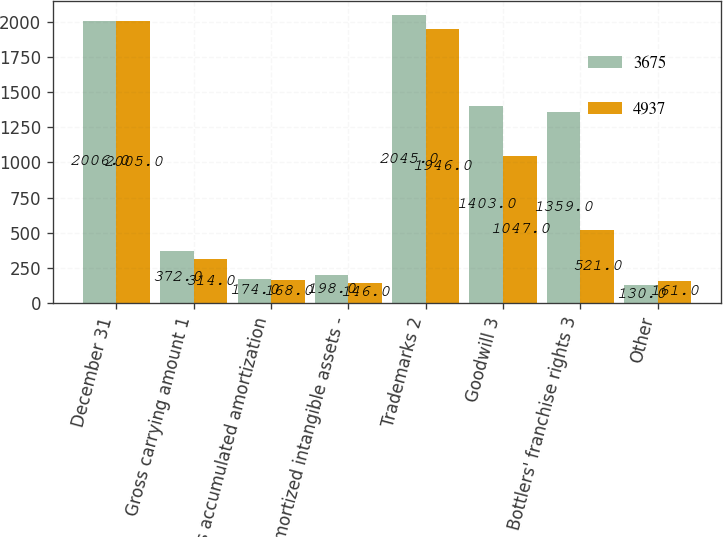Convert chart. <chart><loc_0><loc_0><loc_500><loc_500><stacked_bar_chart><ecel><fcel>December 31<fcel>Gross carrying amount 1<fcel>Less accumulated amortization<fcel>Amortized intangible assets -<fcel>Trademarks 2<fcel>Goodwill 3<fcel>Bottlers' franchise rights 3<fcel>Other<nl><fcel>3675<fcel>2006<fcel>372<fcel>174<fcel>198<fcel>2045<fcel>1403<fcel>1359<fcel>130<nl><fcel>4937<fcel>2005<fcel>314<fcel>168<fcel>146<fcel>1946<fcel>1047<fcel>521<fcel>161<nl></chart> 